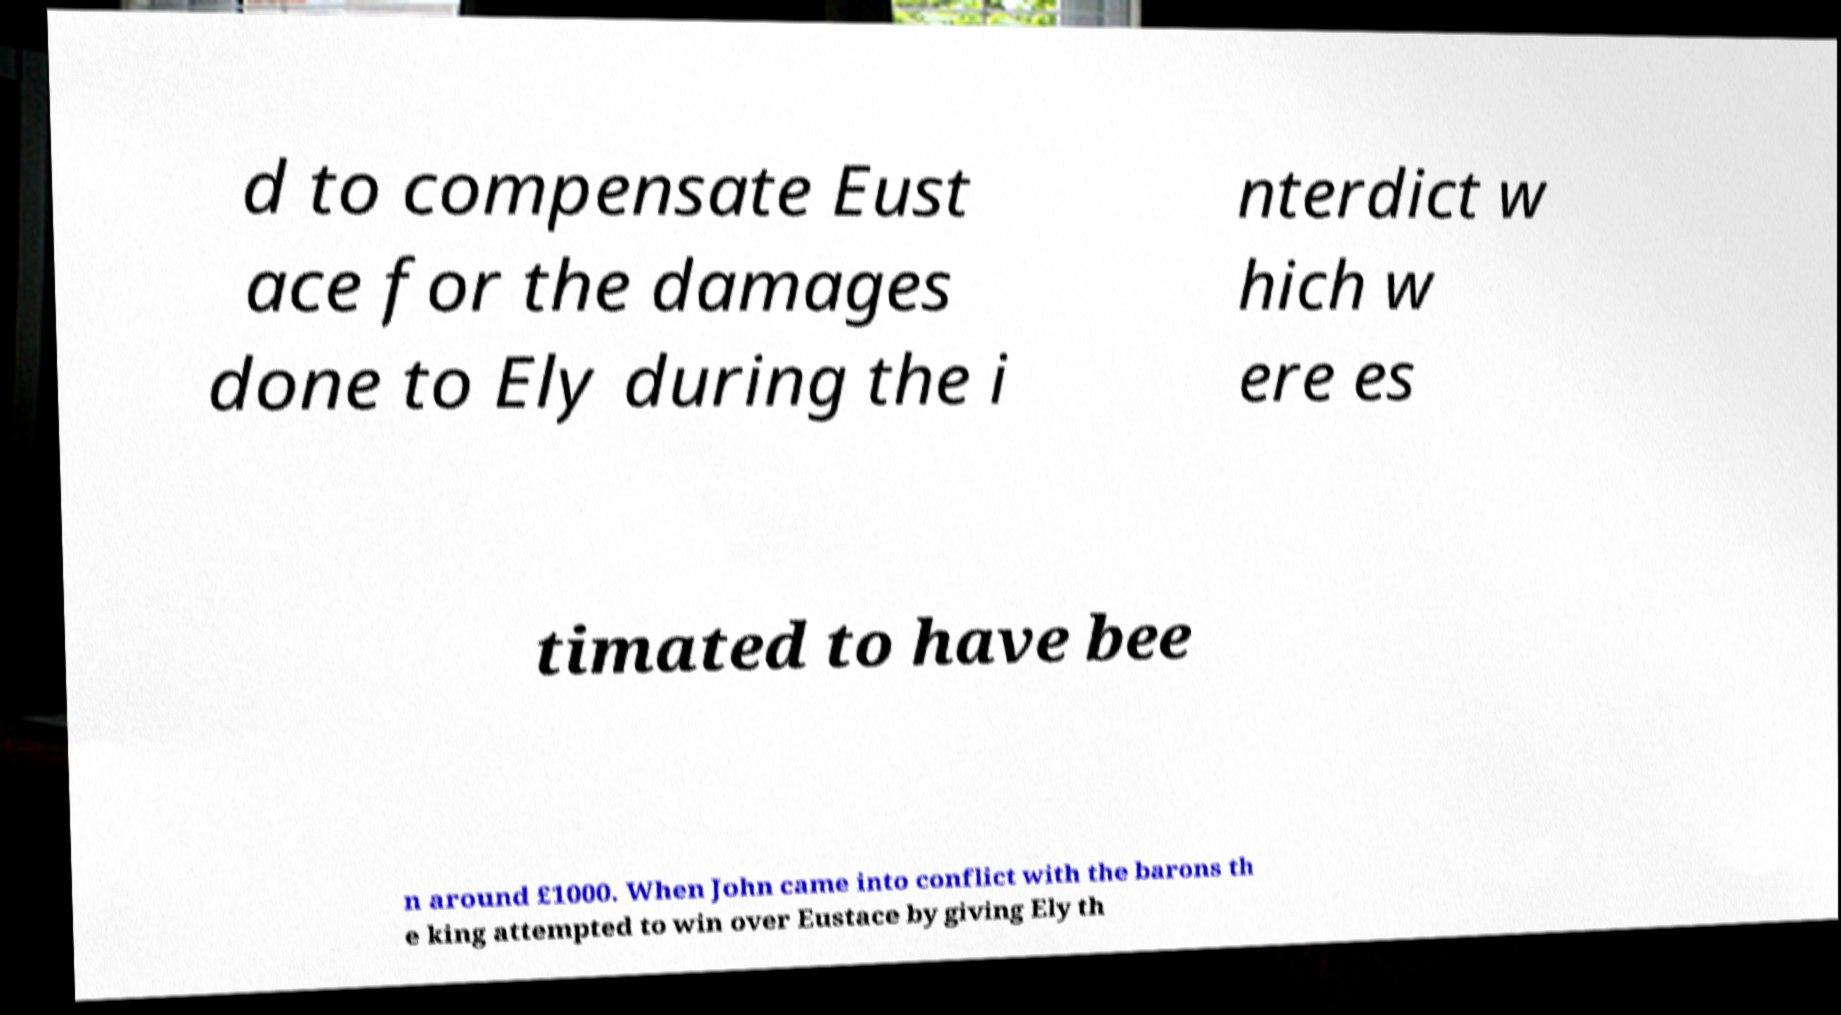Please read and relay the text visible in this image. What does it say? d to compensate Eust ace for the damages done to Ely during the i nterdict w hich w ere es timated to have bee n around £1000. When John came into conflict with the barons th e king attempted to win over Eustace by giving Ely th 